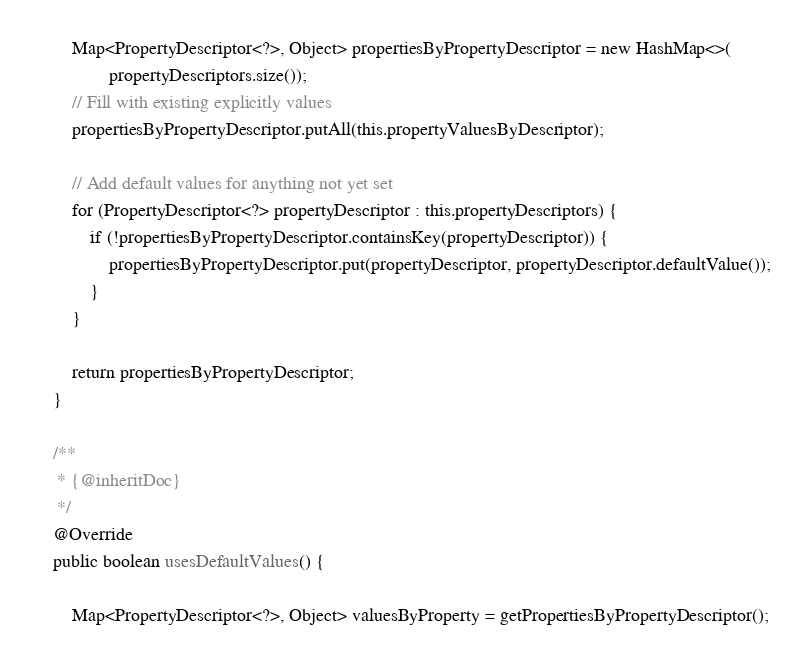Convert code to text. <code><loc_0><loc_0><loc_500><loc_500><_Java_>        Map<PropertyDescriptor<?>, Object> propertiesByPropertyDescriptor = new HashMap<>(
                propertyDescriptors.size());
        // Fill with existing explicitly values
        propertiesByPropertyDescriptor.putAll(this.propertyValuesByDescriptor);

        // Add default values for anything not yet set
        for (PropertyDescriptor<?> propertyDescriptor : this.propertyDescriptors) {
            if (!propertiesByPropertyDescriptor.containsKey(propertyDescriptor)) {
                propertiesByPropertyDescriptor.put(propertyDescriptor, propertyDescriptor.defaultValue());
            }
        }

        return propertiesByPropertyDescriptor;
    }

    /**
     * {@inheritDoc}
     */
    @Override
    public boolean usesDefaultValues() {

        Map<PropertyDescriptor<?>, Object> valuesByProperty = getPropertiesByPropertyDescriptor();</code> 